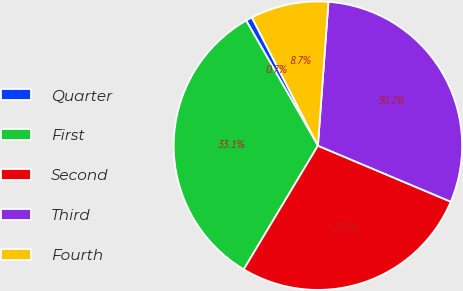<chart> <loc_0><loc_0><loc_500><loc_500><pie_chart><fcel>Quarter<fcel>First<fcel>Second<fcel>Third<fcel>Fourth<nl><fcel>0.72%<fcel>33.12%<fcel>27.25%<fcel>30.19%<fcel>8.73%<nl></chart> 